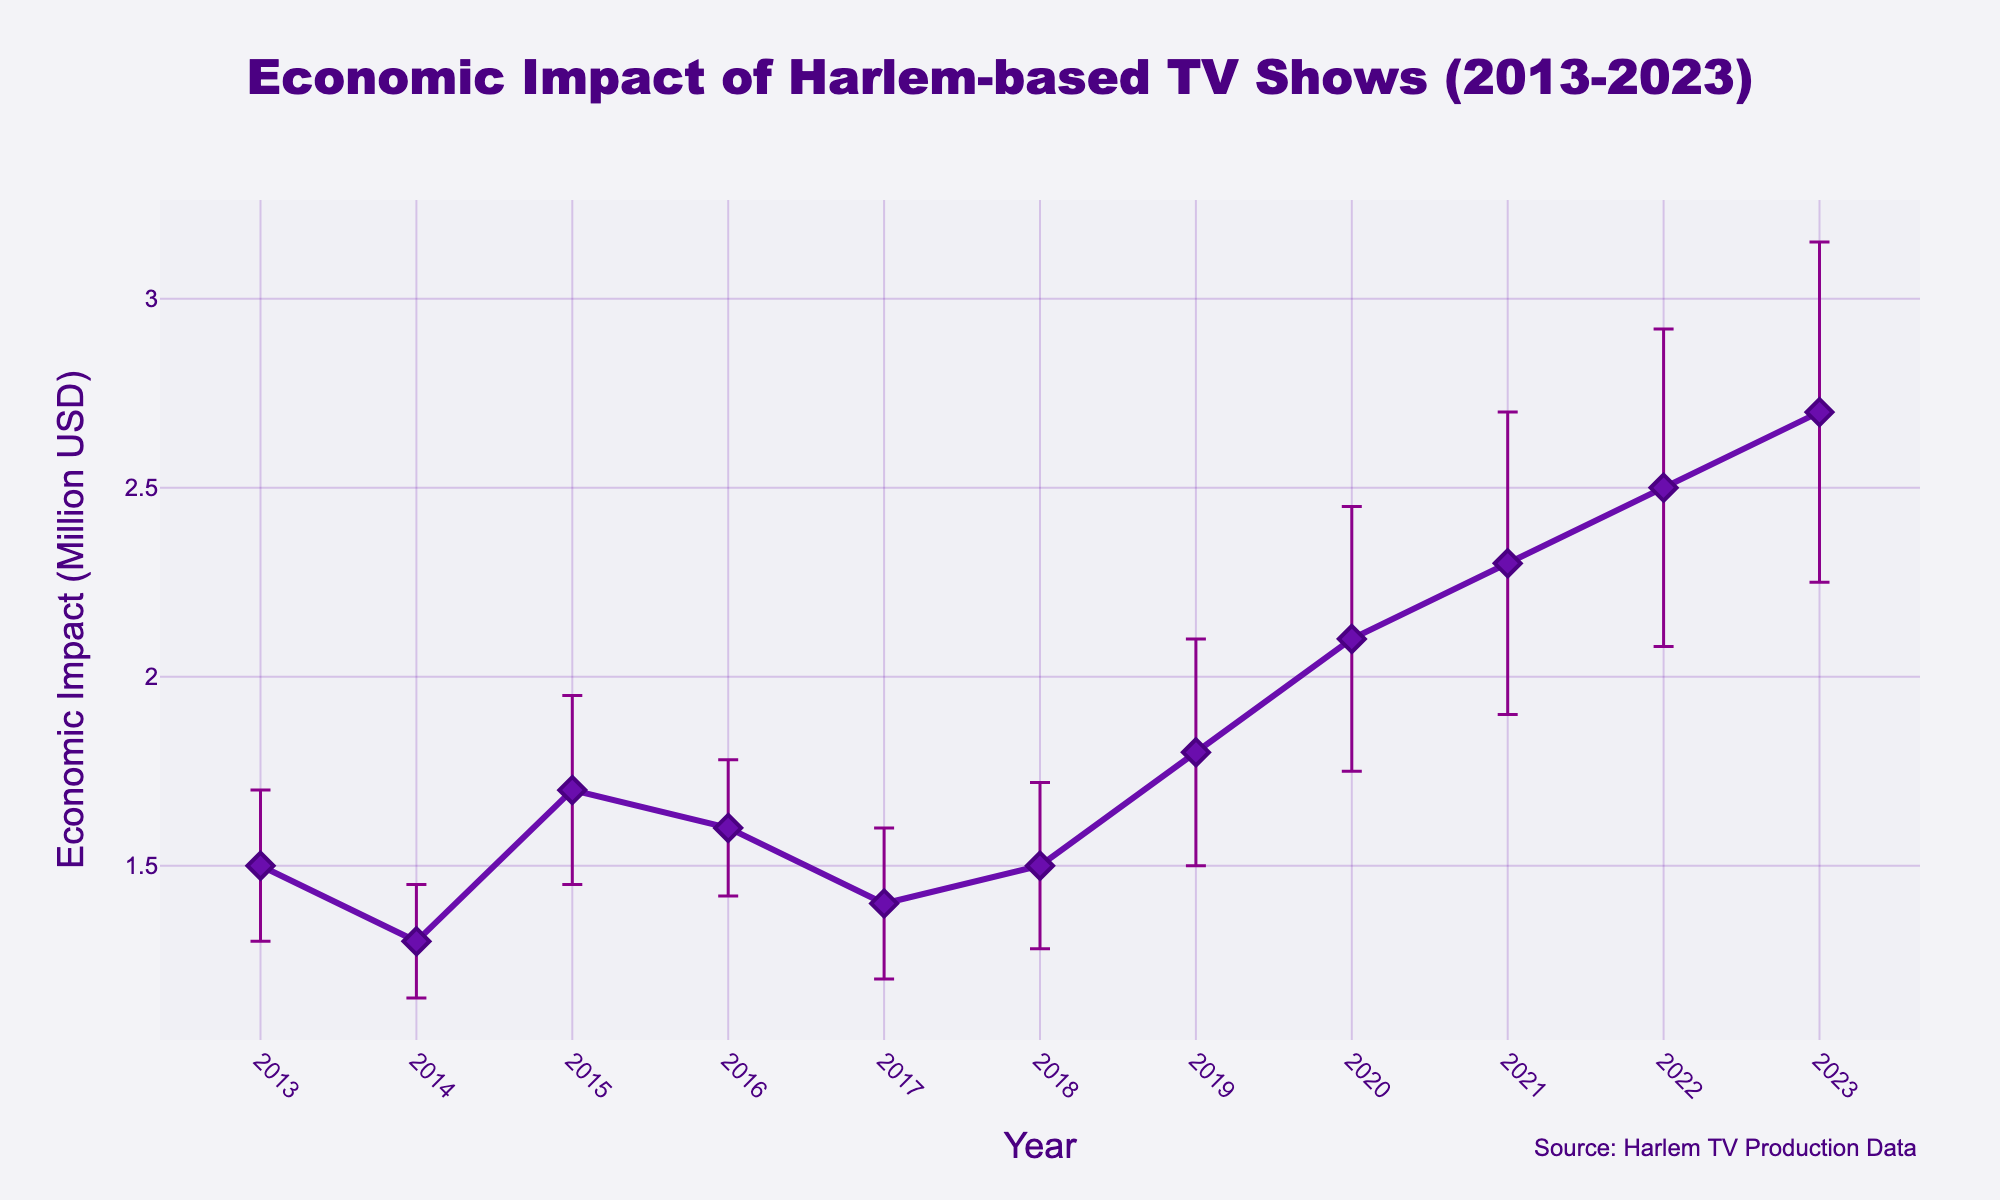Which year shows the highest economic impact in Harlem-based TV shows? Look at the y-axis for Economic Impact and identify the peak point. The highest point shows the highest economic impact.
Answer: 2023 By how much did the economic impact increase from 2013 to 2023? Identify the economic impacts for 2013 and 2023, then subtract the 2013 value from the 2023 value.
Answer: 1.2 million USD Which year has the least economic impact, and what is its value? Identify the lowest point on the y-axis for Economic Impact. The corresponding year and value are the answers.
Answer: 2014, 1.3 million USD What is the average economic impact over the decade? Add up the economic impacts from 2013 to 2023 and divide by the number of years (11). Step-by-step: (1.5 + 1.3 + 1.7 + 1.6 + 1.4 + 1.5 + 1.8 + 2.1 + 2.3 + 2.5 + 2.7) / 11 = 19.4 / 11 = 1.76
Answer: 1.76 million USD In which year did the economic impact first exceed 2 million USD? Look at the points on the y-axis for Economic Impact and identify the first point that exceeds 2 million USD.
Answer: 2020 Which year has the largest standard error in economic impact, and what is its value? Identify the year with the longest error bar on the y-axis. The corresponding year and value are the answers.
Answer: 2023, 0.45 million USD How does the economic impact trend change from 2019 to 2023? Observe the line plot from 2019 to 2023, noting if it goes up, down, or stays stable. The trend is an increasing pattern.
Answer: Increasing What’s the difference in the number of scenes filmed between 2013 and 2023? Identify the number of scenes shot in each year from the data and subtract the 2013 value from the 2023 value (75 - 52).
Answer: 23 scenes Which two years show similar economic impacts, and what are those values? Identify two years where the y-axis points are close or overlap.
Answer: 2018 and 2013, both around 1.5 million USD What’s the general trend in the economic impact from 2013 to 2023? Observe the overall direction of the line plot over the years, whether it rises, falls, or fluctuates.
Answer: Increasing 